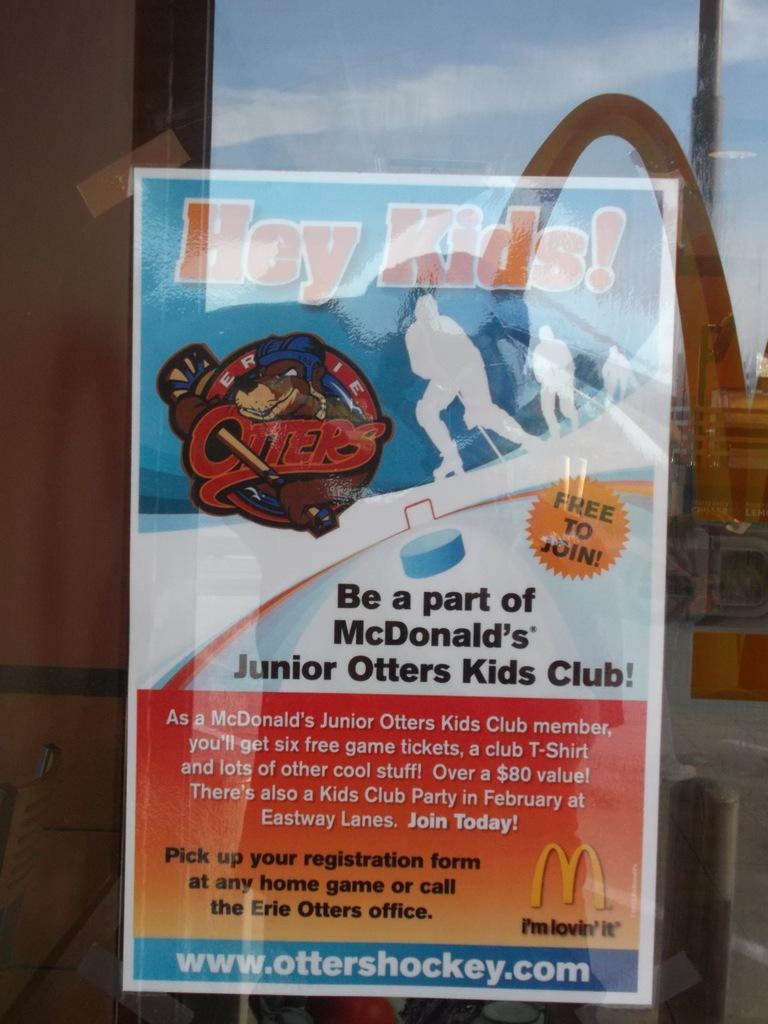<image>
Summarize the visual content of the image. A posted sign in the window shows how to join the McDonald's Junior Otters Kids Club. 